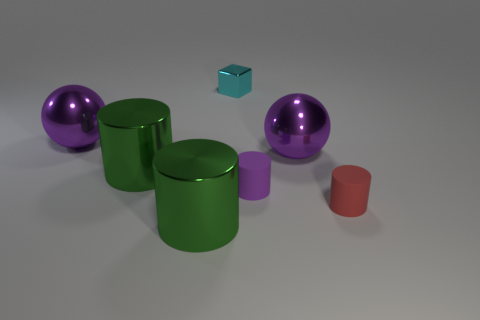Subtract all red rubber cylinders. How many cylinders are left? 3 Add 2 small metallic blocks. How many objects exist? 9 Subtract all green cylinders. How many cylinders are left? 2 Subtract 1 cylinders. How many cylinders are left? 3 Subtract all yellow blocks. How many green cylinders are left? 2 Subtract all yellow balls. Subtract all gray blocks. How many balls are left? 2 Subtract all balls. How many objects are left? 5 Subtract all large balls. Subtract all tiny cyan things. How many objects are left? 4 Add 1 purple rubber cylinders. How many purple rubber cylinders are left? 2 Add 6 tiny metallic blocks. How many tiny metallic blocks exist? 7 